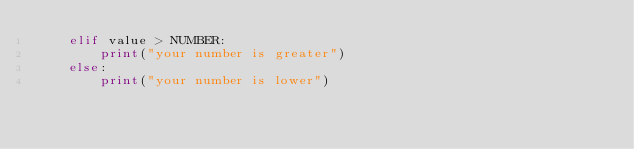Convert code to text. <code><loc_0><loc_0><loc_500><loc_500><_Python_>    elif value > NUMBER:
        print("your number is greater")
    else:
        print("your number is lower")
</code> 